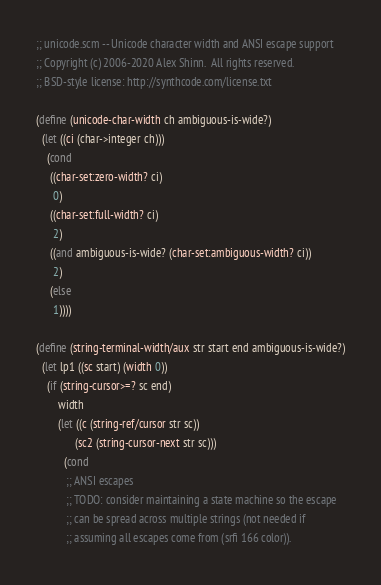Convert code to text. <code><loc_0><loc_0><loc_500><loc_500><_Scheme_>;; unicode.scm -- Unicode character width and ANSI escape support
;; Copyright (c) 2006-2020 Alex Shinn.  All rights reserved.
;; BSD-style license: http://synthcode.com/license.txt

(define (unicode-char-width ch ambiguous-is-wide?)
  (let ((ci (char->integer ch)))
    (cond
     ((char-set:zero-width? ci)
      0)
     ((char-set:full-width? ci)
      2)
     ((and ambiguous-is-wide? (char-set:ambiguous-width? ci))
      2)
     (else
      1))))

(define (string-terminal-width/aux str start end ambiguous-is-wide?)
  (let lp1 ((sc start) (width 0))
    (if (string-cursor>=? sc end)
        width
        (let ((c (string-ref/cursor str sc))
              (sc2 (string-cursor-next str sc)))
          (cond
           ;; ANSI escapes
           ;; TODO: consider maintaining a state machine so the escape
           ;; can be spread across multiple strings (not needed if
           ;; assuming all escapes come from (srfi 166 color)).</code> 